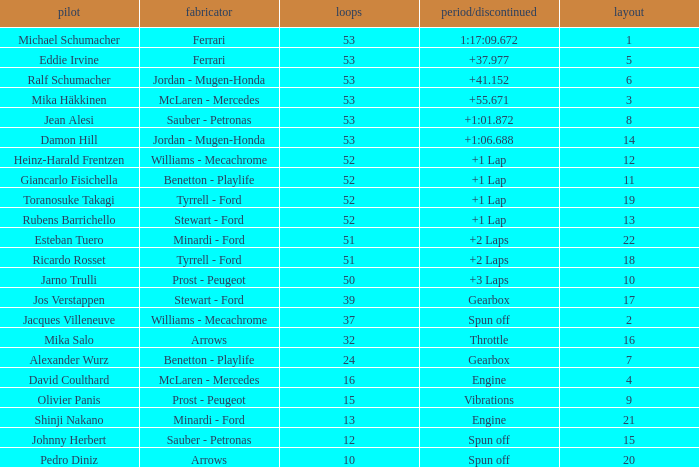Who built the car that went 53 laps with a Time/Retired of 1:17:09.672? Ferrari. 